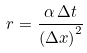<formula> <loc_0><loc_0><loc_500><loc_500>r = { \frac { \alpha \, \Delta t } { \left ( \Delta x \right ) ^ { 2 } } }</formula> 